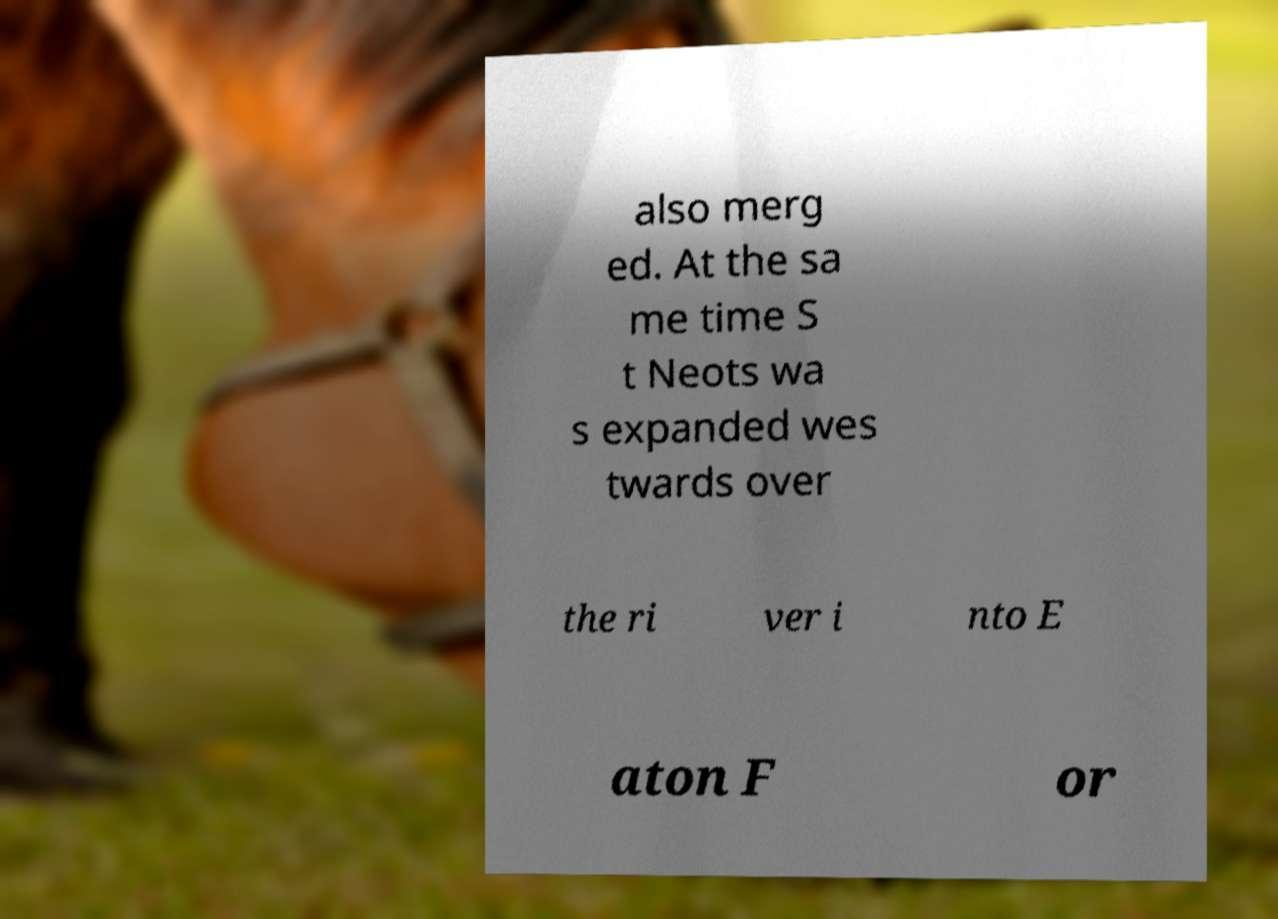What messages or text are displayed in this image? I need them in a readable, typed format. also merg ed. At the sa me time S t Neots wa s expanded wes twards over the ri ver i nto E aton F or 